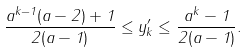Convert formula to latex. <formula><loc_0><loc_0><loc_500><loc_500>\frac { a ^ { k - 1 } ( a - 2 ) + 1 } { 2 ( a - 1 ) } \leq y _ { k } ^ { \prime } \leq \frac { a ^ { k } - 1 } { 2 ( a - 1 ) } .</formula> 